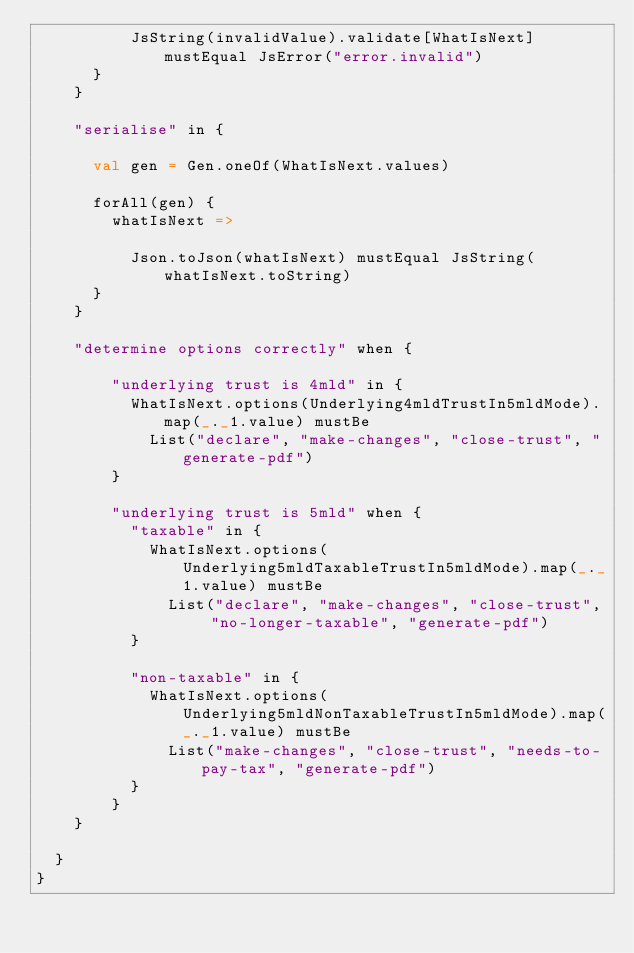<code> <loc_0><loc_0><loc_500><loc_500><_Scala_>          JsString(invalidValue).validate[WhatIsNext] mustEqual JsError("error.invalid")
      }
    }

    "serialise" in {

      val gen = Gen.oneOf(WhatIsNext.values)

      forAll(gen) {
        whatIsNext =>

          Json.toJson(whatIsNext) mustEqual JsString(whatIsNext.toString)
      }
    }

    "determine options correctly" when {

        "underlying trust is 4mld" in {
          WhatIsNext.options(Underlying4mldTrustIn5mldMode).map(_._1.value) mustBe
            List("declare", "make-changes", "close-trust", "generate-pdf")
        }

        "underlying trust is 5mld" when {
          "taxable" in {
            WhatIsNext.options(Underlying5mldTaxableTrustIn5mldMode).map(_._1.value) mustBe
              List("declare", "make-changes", "close-trust", "no-longer-taxable", "generate-pdf")
          }

          "non-taxable" in {
            WhatIsNext.options(Underlying5mldNonTaxableTrustIn5mldMode).map(_._1.value) mustBe
              List("make-changes", "close-trust", "needs-to-pay-tax", "generate-pdf")
          }
        }
    }

  }
}
</code> 